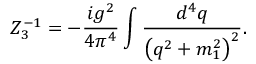<formula> <loc_0><loc_0><loc_500><loc_500>Z _ { 3 } ^ { - 1 } = - \frac { i g ^ { 2 } } { 4 \pi ^ { 4 } } \int \frac { d ^ { 4 } q } { \left ( q ^ { 2 } + m _ { 1 } ^ { 2 } \right ) ^ { 2 } } .</formula> 